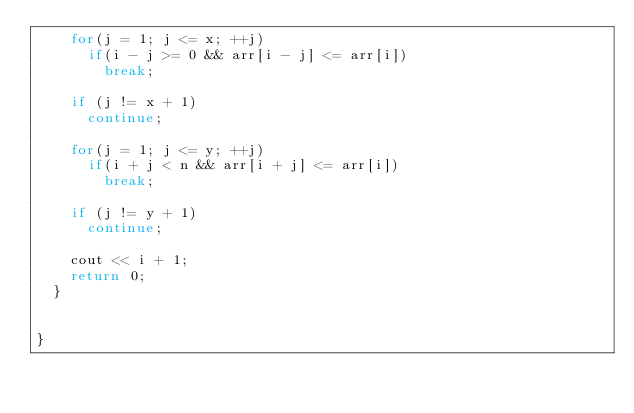Convert code to text. <code><loc_0><loc_0><loc_500><loc_500><_C++_>    for(j = 1; j <= x; ++j)
      if(i - j >= 0 && arr[i - j] <= arr[i])
        break; 
    
    if (j != x + 1)
      continue;

    for(j = 1; j <= y; ++j)
      if(i + j < n && arr[i + j] <= arr[i])
        break;

    if (j != y + 1)
      continue;
    
    cout << i + 1;
    return 0;
  }


}
</code> 